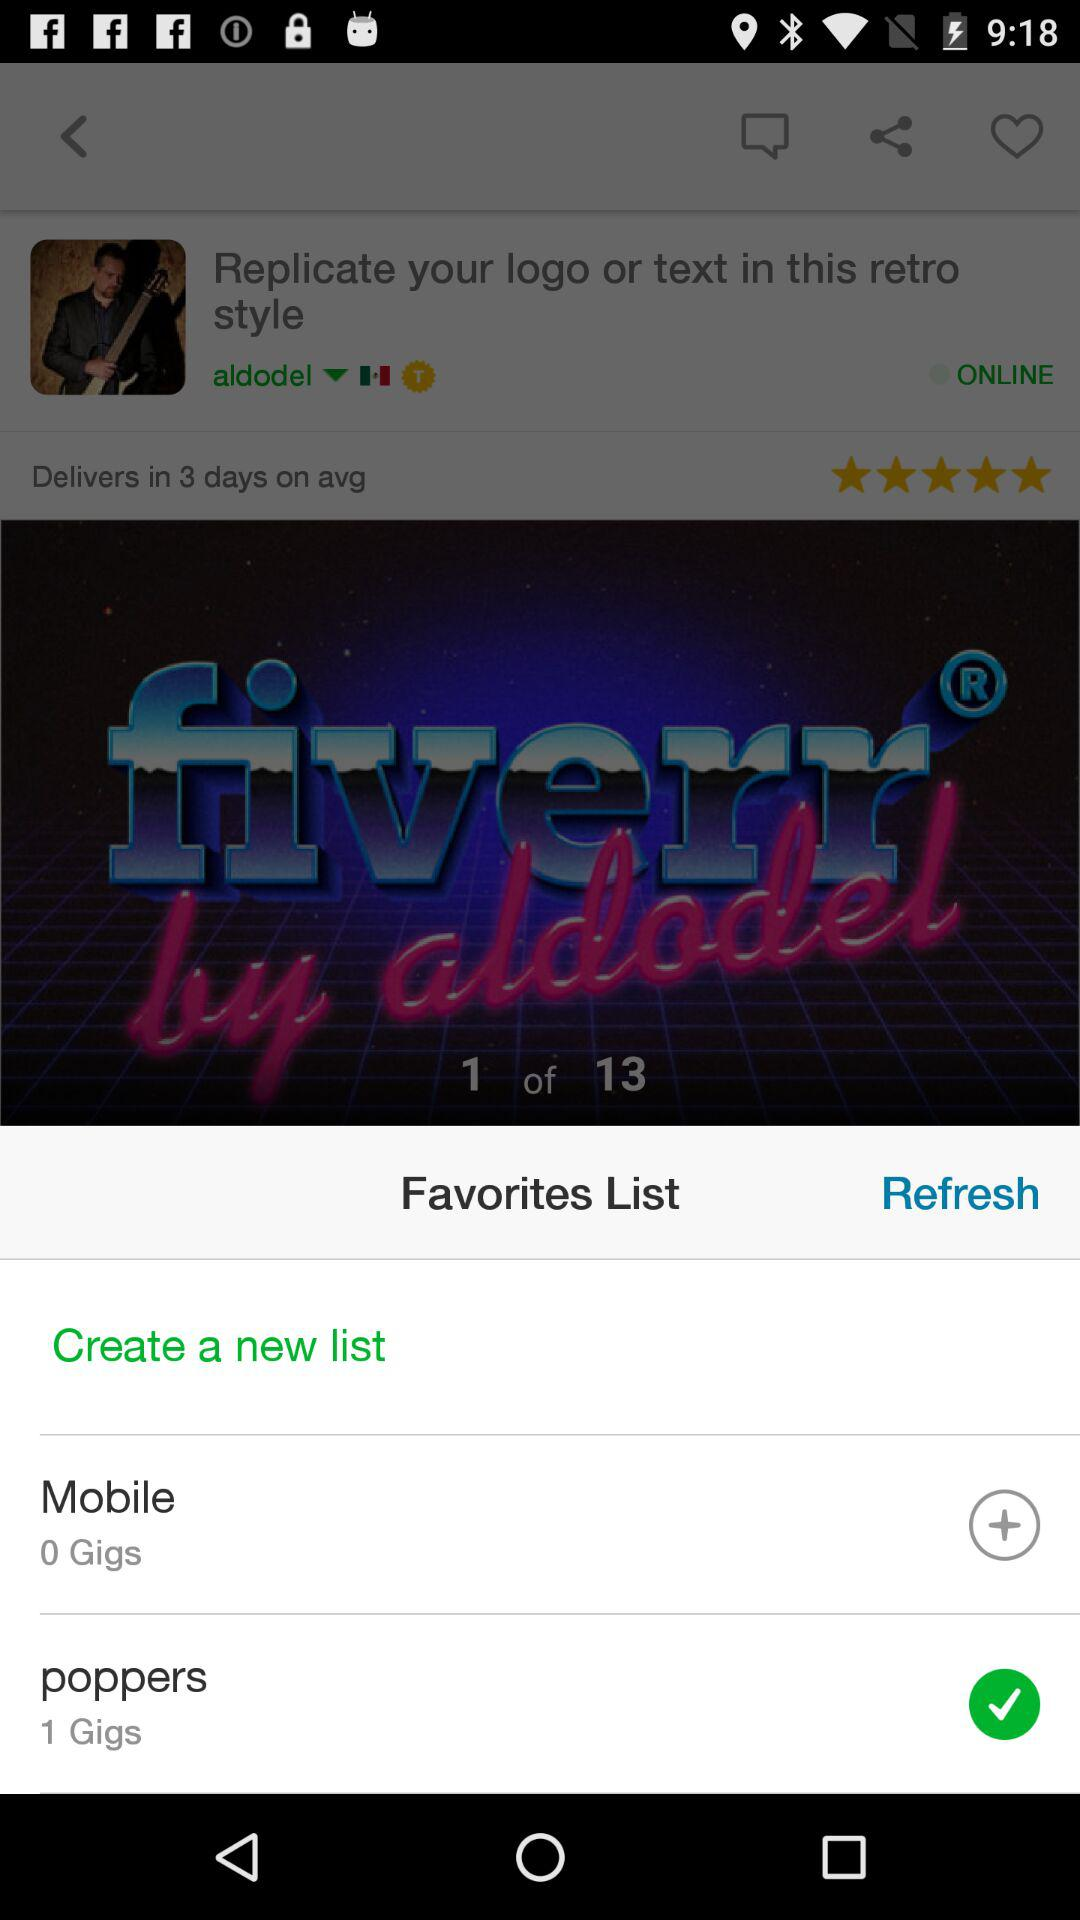What is the rating? The rating is 5 stars. 